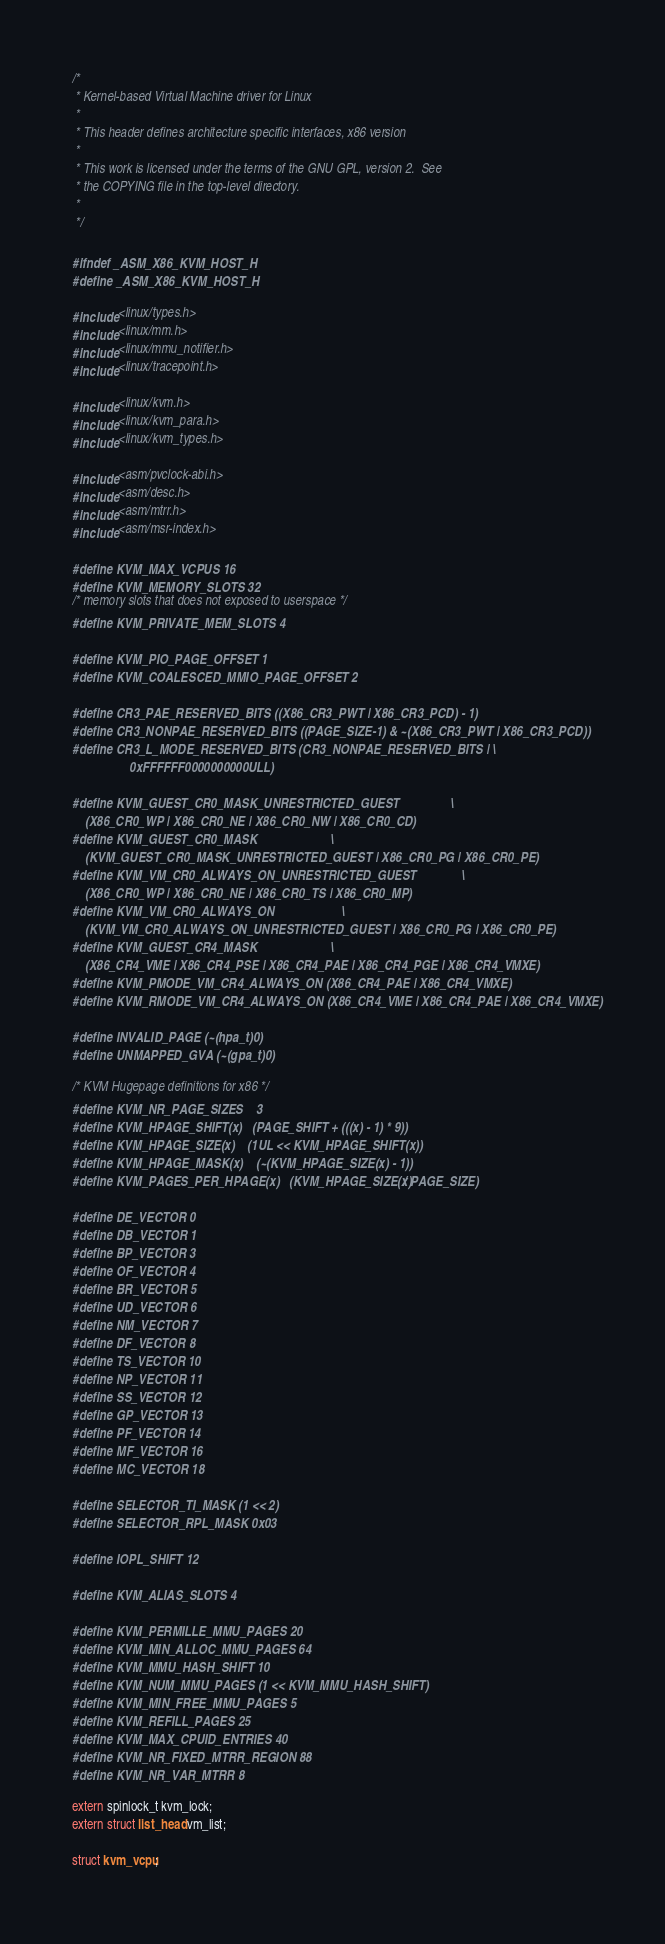<code> <loc_0><loc_0><loc_500><loc_500><_C_>/*
 * Kernel-based Virtual Machine driver for Linux
 *
 * This header defines architecture specific interfaces, x86 version
 *
 * This work is licensed under the terms of the GNU GPL, version 2.  See
 * the COPYING file in the top-level directory.
 *
 */

#ifndef _ASM_X86_KVM_HOST_H
#define _ASM_X86_KVM_HOST_H

#include <linux/types.h>
#include <linux/mm.h>
#include <linux/mmu_notifier.h>
#include <linux/tracepoint.h>

#include <linux/kvm.h>
#include <linux/kvm_para.h>
#include <linux/kvm_types.h>

#include <asm/pvclock-abi.h>
#include <asm/desc.h>
#include <asm/mtrr.h>
#include <asm/msr-index.h>

#define KVM_MAX_VCPUS 16
#define KVM_MEMORY_SLOTS 32
/* memory slots that does not exposed to userspace */
#define KVM_PRIVATE_MEM_SLOTS 4

#define KVM_PIO_PAGE_OFFSET 1
#define KVM_COALESCED_MMIO_PAGE_OFFSET 2

#define CR3_PAE_RESERVED_BITS ((X86_CR3_PWT | X86_CR3_PCD) - 1)
#define CR3_NONPAE_RESERVED_BITS ((PAGE_SIZE-1) & ~(X86_CR3_PWT | X86_CR3_PCD))
#define CR3_L_MODE_RESERVED_BITS (CR3_NONPAE_RESERVED_BITS |	\
				  0xFFFFFF0000000000ULL)

#define KVM_GUEST_CR0_MASK_UNRESTRICTED_GUEST				\
	(X86_CR0_WP | X86_CR0_NE | X86_CR0_NW | X86_CR0_CD)
#define KVM_GUEST_CR0_MASK						\
	(KVM_GUEST_CR0_MASK_UNRESTRICTED_GUEST | X86_CR0_PG | X86_CR0_PE)
#define KVM_VM_CR0_ALWAYS_ON_UNRESTRICTED_GUEST				\
	(X86_CR0_WP | X86_CR0_NE | X86_CR0_TS | X86_CR0_MP)
#define KVM_VM_CR0_ALWAYS_ON						\
	(KVM_VM_CR0_ALWAYS_ON_UNRESTRICTED_GUEST | X86_CR0_PG | X86_CR0_PE)
#define KVM_GUEST_CR4_MASK						\
	(X86_CR4_VME | X86_CR4_PSE | X86_CR4_PAE | X86_CR4_PGE | X86_CR4_VMXE)
#define KVM_PMODE_VM_CR4_ALWAYS_ON (X86_CR4_PAE | X86_CR4_VMXE)
#define KVM_RMODE_VM_CR4_ALWAYS_ON (X86_CR4_VME | X86_CR4_PAE | X86_CR4_VMXE)

#define INVALID_PAGE (~(hpa_t)0)
#define UNMAPPED_GVA (~(gpa_t)0)

/* KVM Hugepage definitions for x86 */
#define KVM_NR_PAGE_SIZES	3
#define KVM_HPAGE_SHIFT(x)	(PAGE_SHIFT + (((x) - 1) * 9))
#define KVM_HPAGE_SIZE(x)	(1UL << KVM_HPAGE_SHIFT(x))
#define KVM_HPAGE_MASK(x)	(~(KVM_HPAGE_SIZE(x) - 1))
#define KVM_PAGES_PER_HPAGE(x)	(KVM_HPAGE_SIZE(x) / PAGE_SIZE)

#define DE_VECTOR 0
#define DB_VECTOR 1
#define BP_VECTOR 3
#define OF_VECTOR 4
#define BR_VECTOR 5
#define UD_VECTOR 6
#define NM_VECTOR 7
#define DF_VECTOR 8
#define TS_VECTOR 10
#define NP_VECTOR 11
#define SS_VECTOR 12
#define GP_VECTOR 13
#define PF_VECTOR 14
#define MF_VECTOR 16
#define MC_VECTOR 18

#define SELECTOR_TI_MASK (1 << 2)
#define SELECTOR_RPL_MASK 0x03

#define IOPL_SHIFT 12

#define KVM_ALIAS_SLOTS 4

#define KVM_PERMILLE_MMU_PAGES 20
#define KVM_MIN_ALLOC_MMU_PAGES 64
#define KVM_MMU_HASH_SHIFT 10
#define KVM_NUM_MMU_PAGES (1 << KVM_MMU_HASH_SHIFT)
#define KVM_MIN_FREE_MMU_PAGES 5
#define KVM_REFILL_PAGES 25
#define KVM_MAX_CPUID_ENTRIES 40
#define KVM_NR_FIXED_MTRR_REGION 88
#define KVM_NR_VAR_MTRR 8

extern spinlock_t kvm_lock;
extern struct list_head vm_list;

struct kvm_vcpu;</code> 